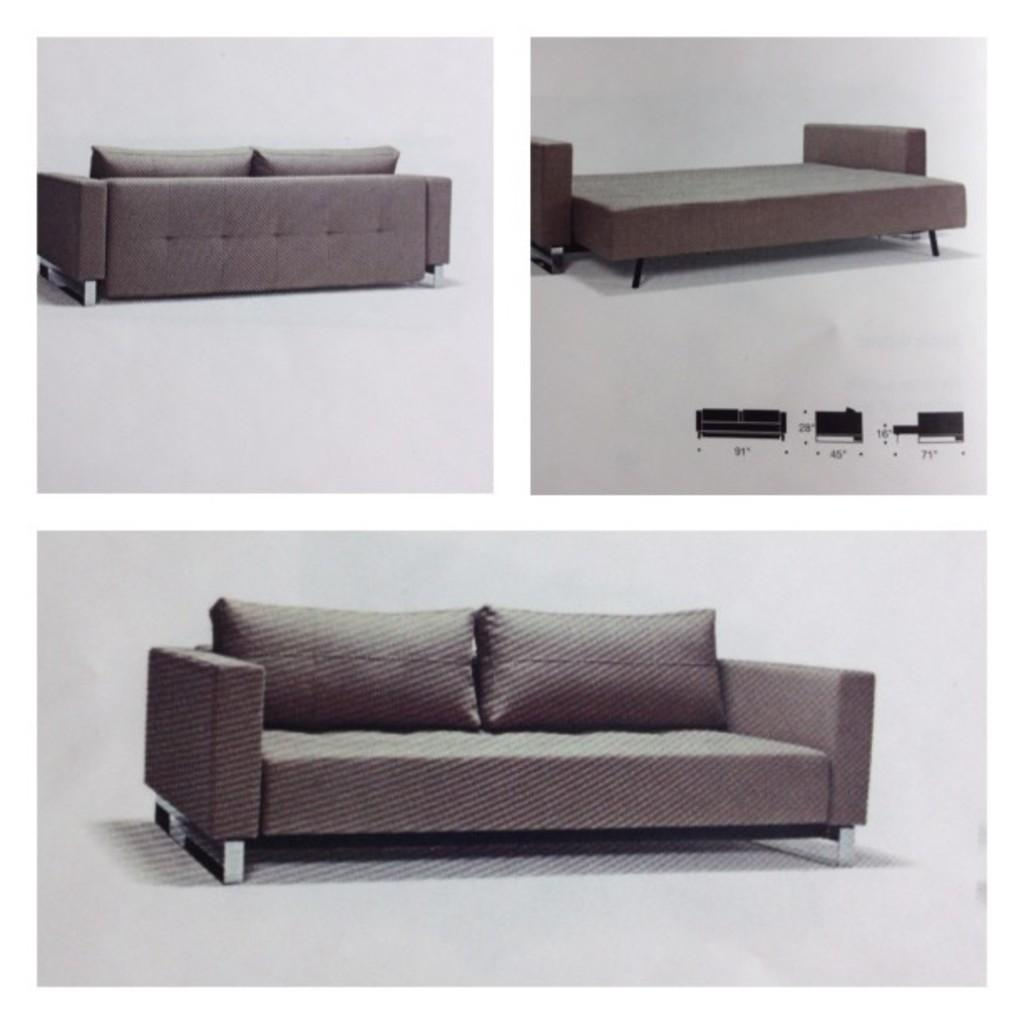What is the main subject of the image? The image contains a photo. What can be seen in the photo? There is a sofa set and a bed in the photo. Are there any additional details about the sofa set? Yes, there are pillows on the sofa. What type of soup is being served on the bed in the photo? There is no soup present in the photo; it features a sofa set and a bed with pillows. What is the title of the photo? The provided facts do not mention a title for the photo. 